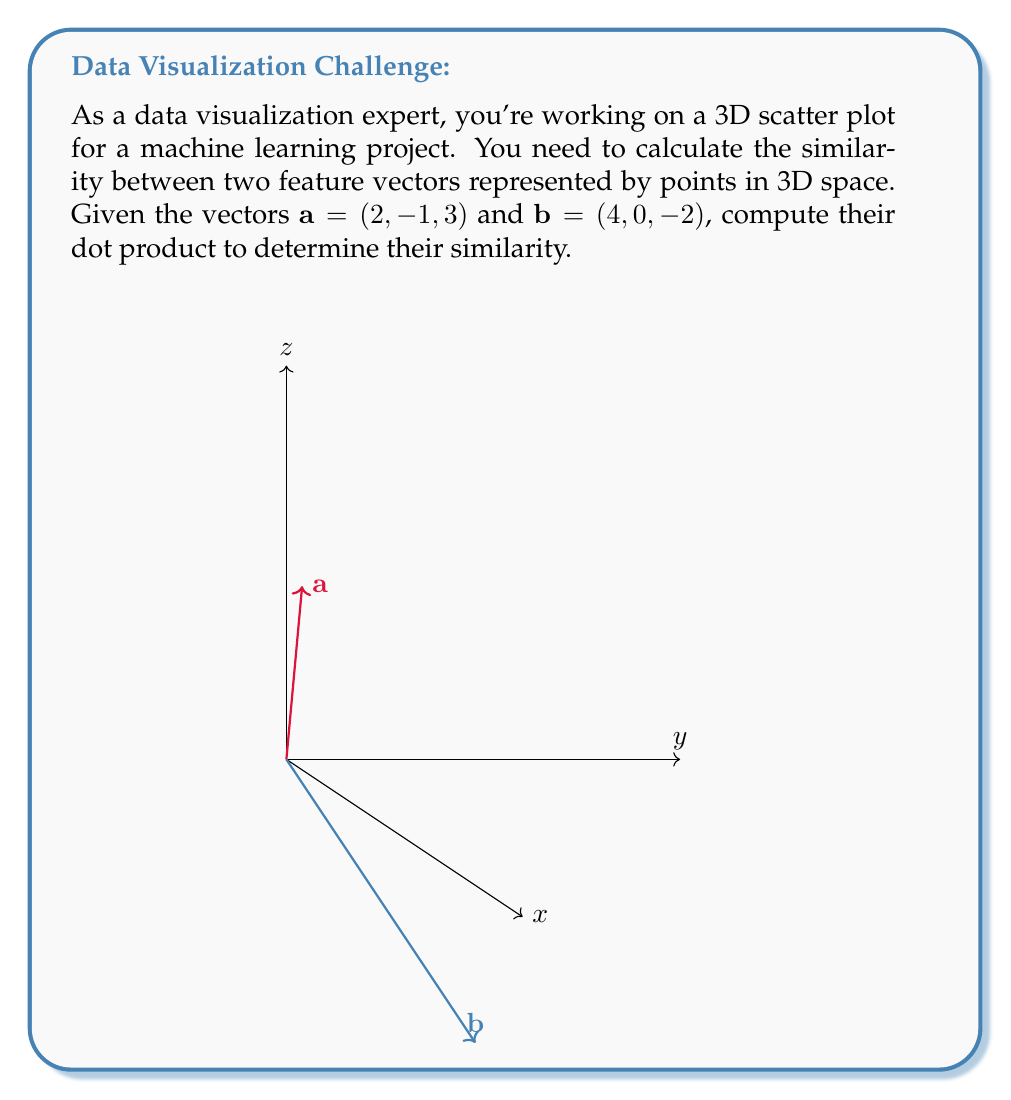Show me your answer to this math problem. To calculate the dot product of two vectors in 3D space, we multiply their corresponding components and sum the results. Let's break it down step-by-step:

1) The dot product formula for 3D vectors $\mathbf{a} = (a_1, a_2, a_3)$ and $\mathbf{b} = (b_1, b_2, b_3)$ is:

   $$\mathbf{a} \cdot \mathbf{b} = a_1b_1 + a_2b_2 + a_3b_3$$

2) We have $\mathbf{a} = (2, -1, 3)$ and $\mathbf{b} = (4, 0, -2)$. Let's substitute these values:

   $$\mathbf{a} \cdot \mathbf{b} = (2)(4) + (-1)(0) + (3)(-2)$$

3) Now, let's calculate each term:
   - First term: $2 \times 4 = 8$
   - Second term: $-1 \times 0 = 0$
   - Third term: $3 \times (-2) = -6$

4) Sum up all the terms:

   $$\mathbf{a} \cdot \mathbf{b} = 8 + 0 + (-6) = 2$$

The dot product represents the similarity between vectors. A positive result indicates that the vectors point in generally the same direction, while a negative result would indicate they point in generally opposite directions. The magnitude of the result indicates how similar they are.
Answer: $2$ 